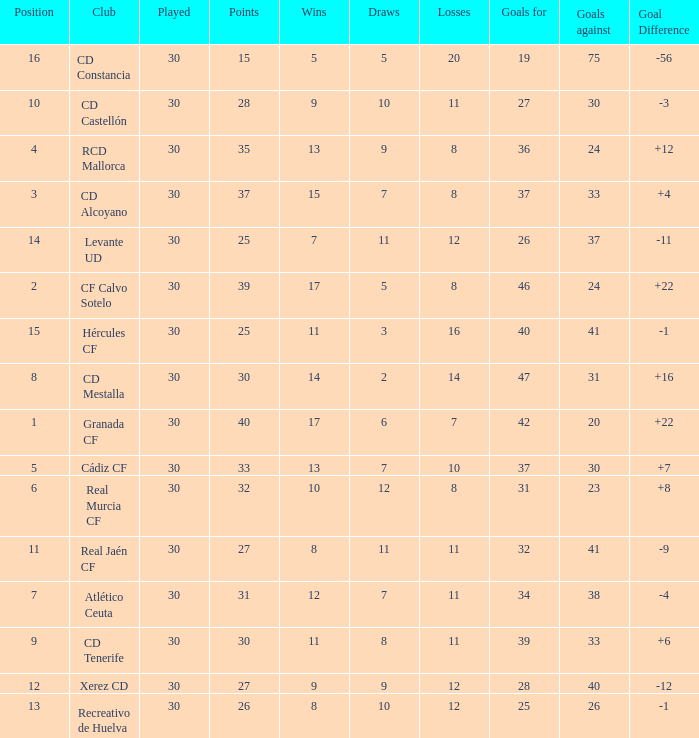Could you help me parse every detail presented in this table? {'header': ['Position', 'Club', 'Played', 'Points', 'Wins', 'Draws', 'Losses', 'Goals for', 'Goals against', 'Goal Difference'], 'rows': [['16', 'CD Constancia', '30', '15', '5', '5', '20', '19', '75', '-56'], ['10', 'CD Castellón', '30', '28', '9', '10', '11', '27', '30', '-3'], ['4', 'RCD Mallorca', '30', '35', '13', '9', '8', '36', '24', '+12'], ['3', 'CD Alcoyano', '30', '37', '15', '7', '8', '37', '33', '+4'], ['14', 'Levante UD', '30', '25', '7', '11', '12', '26', '37', '-11'], ['2', 'CF Calvo Sotelo', '30', '39', '17', '5', '8', '46', '24', '+22'], ['15', 'Hércules CF', '30', '25', '11', '3', '16', '40', '41', '-1'], ['8', 'CD Mestalla', '30', '30', '14', '2', '14', '47', '31', '+16'], ['1', 'Granada CF', '30', '40', '17', '6', '7', '42', '20', '+22'], ['5', 'Cádiz CF', '30', '33', '13', '7', '10', '37', '30', '+7'], ['6', 'Real Murcia CF', '30', '32', '10', '12', '8', '31', '23', '+8'], ['11', 'Real Jaén CF', '30', '27', '8', '11', '11', '32', '41', '-9'], ['7', 'Atlético Ceuta', '30', '31', '12', '7', '11', '34', '38', '-4'], ['9', 'CD Tenerife', '30', '30', '11', '8', '11', '39', '33', '+6'], ['12', 'Xerez CD', '30', '27', '9', '9', '12', '28', '40', '-12'], ['13', 'Recreativo de Huelva', '30', '26', '8', '10', '12', '25', '26', '-1']]} Which Played has a Club of atlético ceuta, and less than 11 Losses? None. 